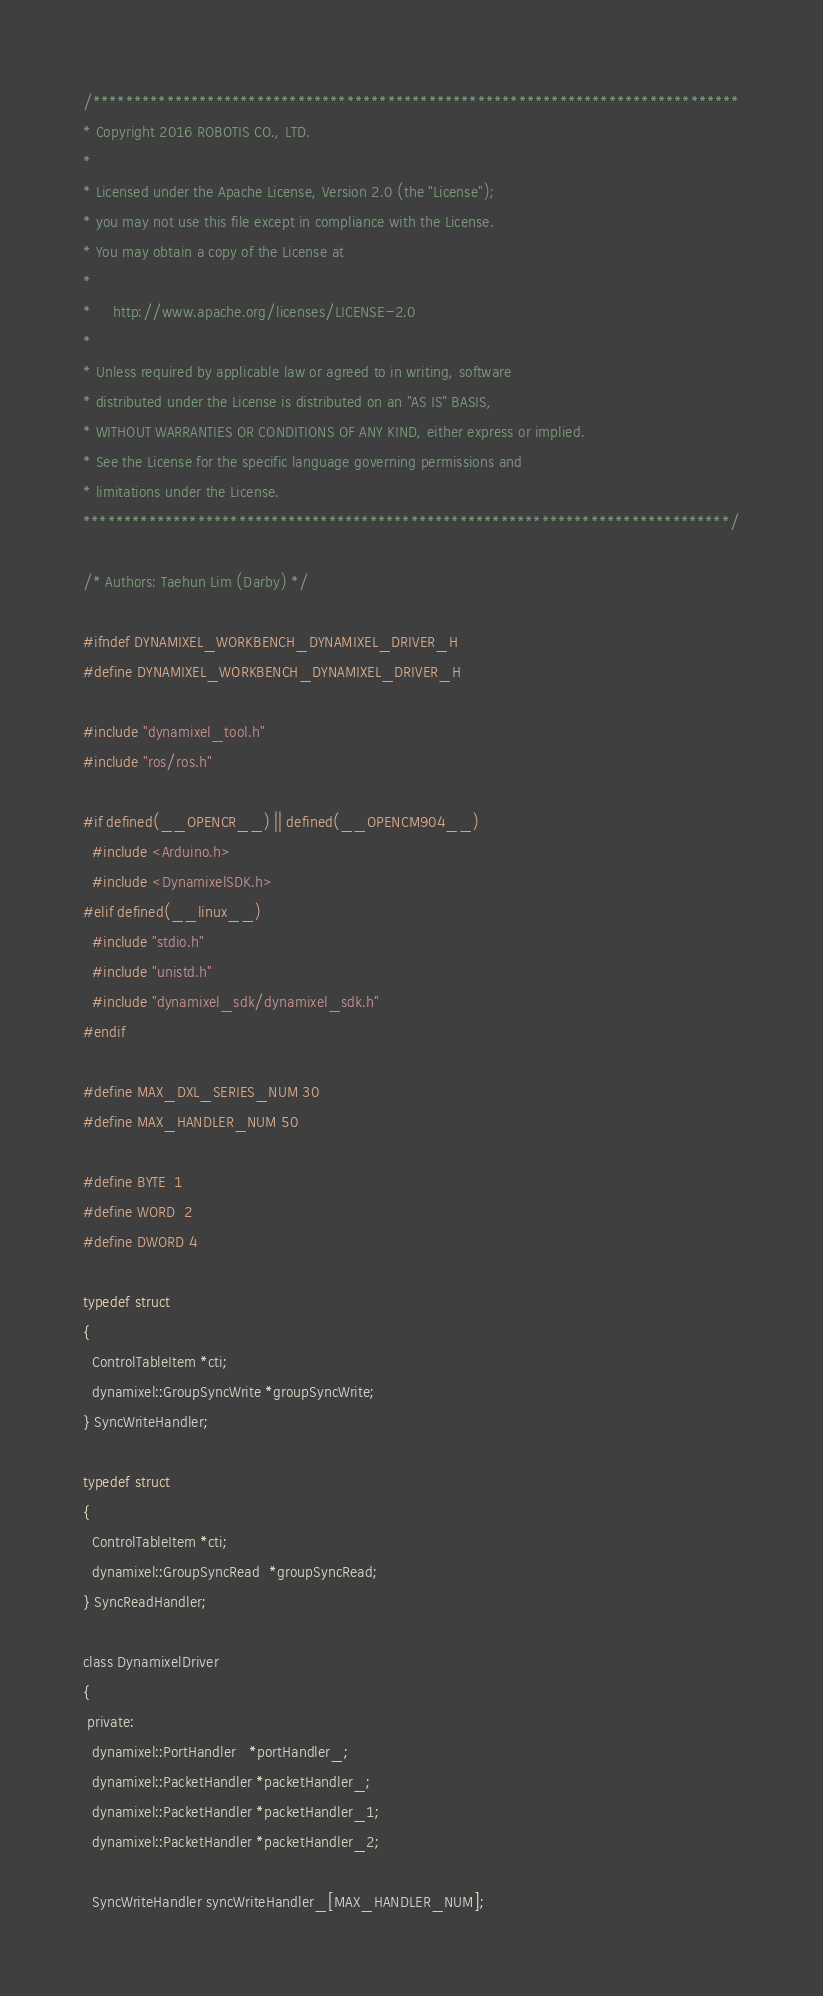<code> <loc_0><loc_0><loc_500><loc_500><_C_>/*******************************************************************************
* Copyright 2016 ROBOTIS CO., LTD.
*
* Licensed under the Apache License, Version 2.0 (the "License");
* you may not use this file except in compliance with the License.
* You may obtain a copy of the License at
*
*     http://www.apache.org/licenses/LICENSE-2.0
*
* Unless required by applicable law or agreed to in writing, software
* distributed under the License is distributed on an "AS IS" BASIS,
* WITHOUT WARRANTIES OR CONDITIONS OF ANY KIND, either express or implied.
* See the License for the specific language governing permissions and
* limitations under the License.
*******************************************************************************/

/* Authors: Taehun Lim (Darby) */

#ifndef DYNAMIXEL_WORKBENCH_DYNAMIXEL_DRIVER_H
#define DYNAMIXEL_WORKBENCH_DYNAMIXEL_DRIVER_H

#include "dynamixel_tool.h"
#include "ros/ros.h"

#if defined(__OPENCR__) || defined(__OPENCM904__)
  #include <Arduino.h>
  #include <DynamixelSDK.h>
#elif defined(__linux__)
  #include "stdio.h"
  #include "unistd.h"
  #include "dynamixel_sdk/dynamixel_sdk.h"
#endif

#define MAX_DXL_SERIES_NUM 30
#define MAX_HANDLER_NUM 50

#define BYTE  1
#define WORD  2
#define DWORD 4

typedef struct 
{
  ControlTableItem *cti; 
  dynamixel::GroupSyncWrite *groupSyncWrite;    
} SyncWriteHandler;

typedef struct 
{
  ControlTableItem *cti;
  dynamixel::GroupSyncRead  *groupSyncRead;     
} SyncReadHandler;

class DynamixelDriver
{
 private:
  dynamixel::PortHandler   *portHandler_;
  dynamixel::PacketHandler *packetHandler_;
  dynamixel::PacketHandler *packetHandler_1;
  dynamixel::PacketHandler *packetHandler_2;

  SyncWriteHandler syncWriteHandler_[MAX_HANDLER_NUM];</code> 